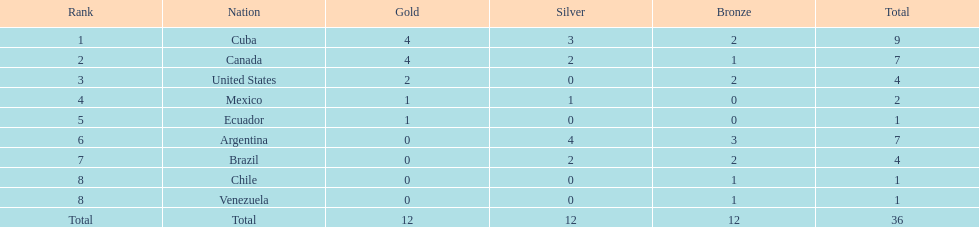Where does mexico stand in the rankings? 4. 